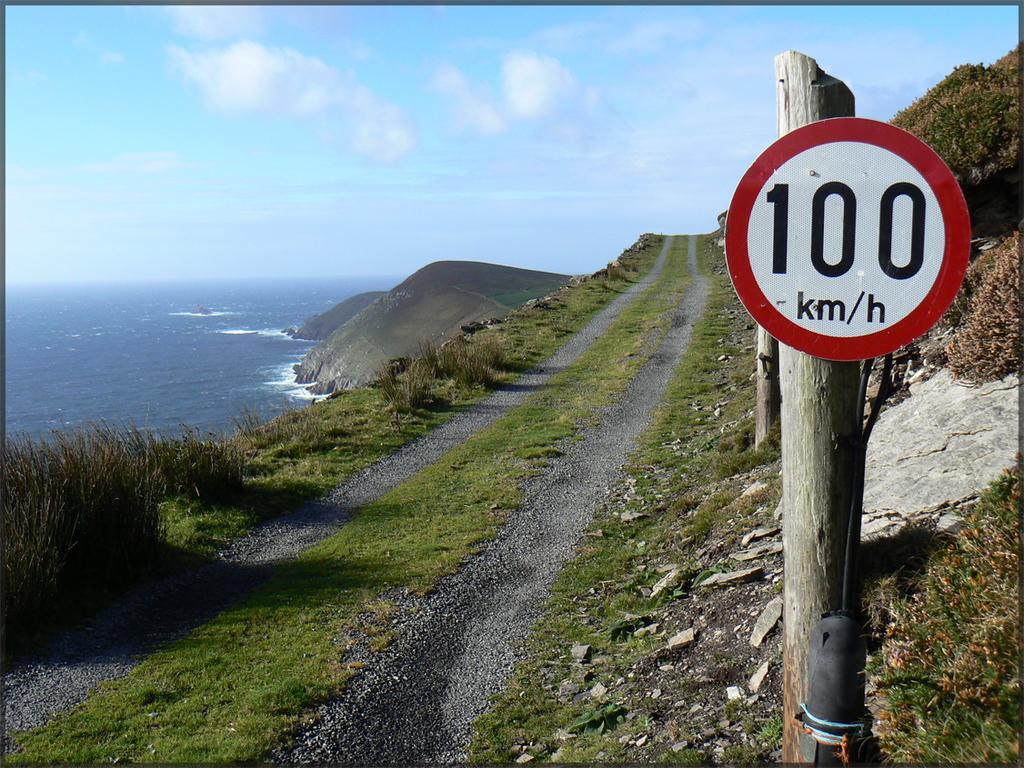<image>
Write a terse but informative summary of the picture. A round sign has the number 100 on it. 